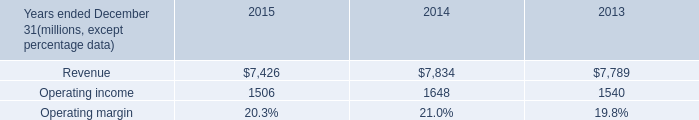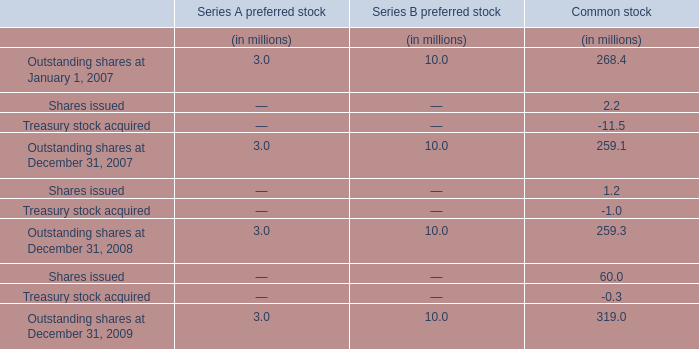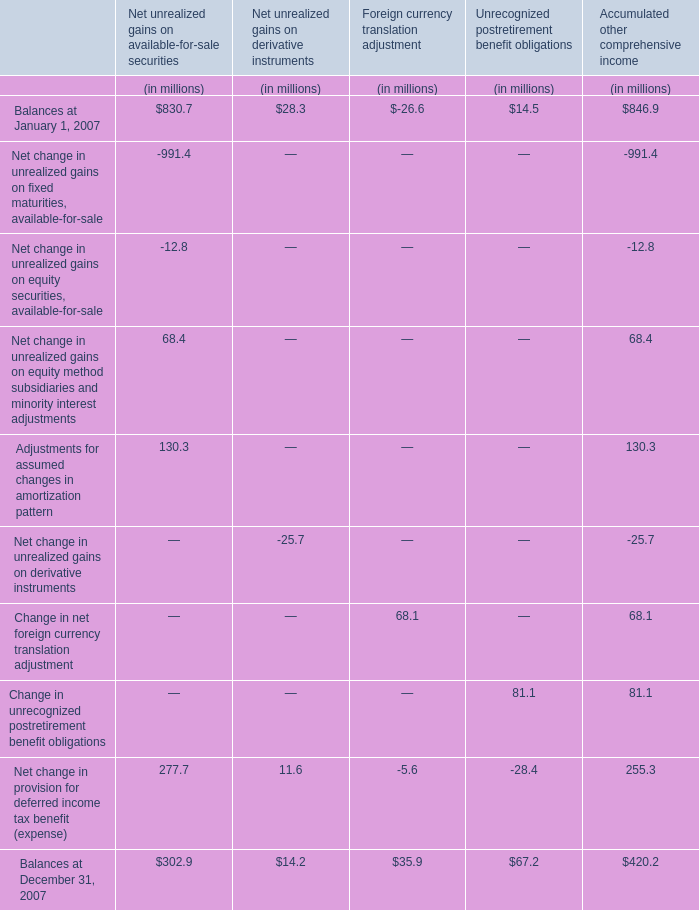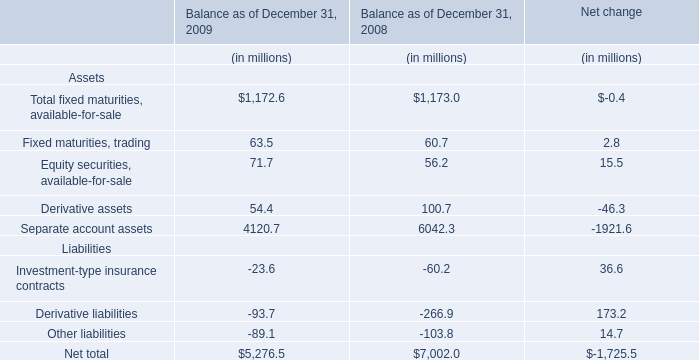What is the ratio of Foreign currency translation adjustment for Net change in provision for deferred income tax benefit (expense) to the total in 2007? 
Computations: (-5.6 / 255.3)
Answer: -0.02193. 